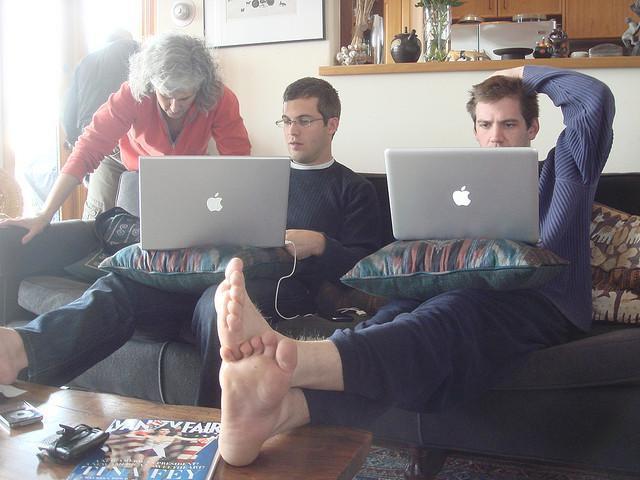How many computers are there?
Give a very brief answer. 2. How many laptops are there?
Give a very brief answer. 2. How many people are there?
Give a very brief answer. 3. How many couches are in the photo?
Give a very brief answer. 2. 